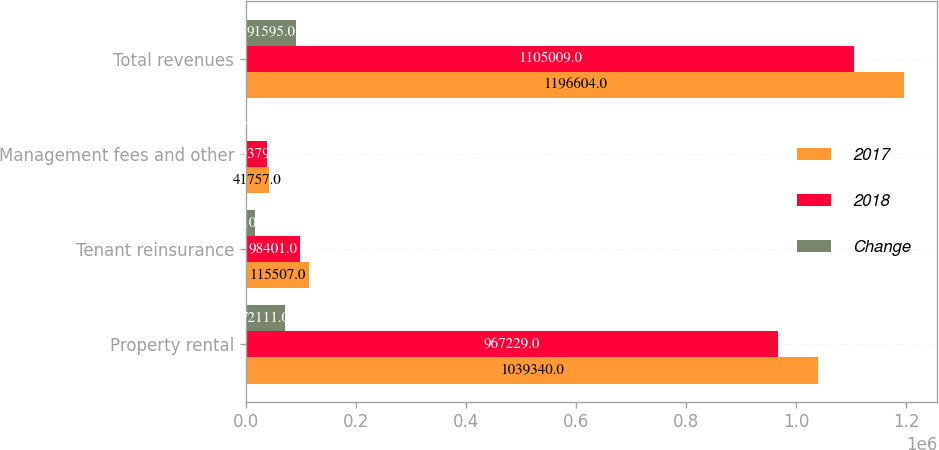Convert chart to OTSL. <chart><loc_0><loc_0><loc_500><loc_500><stacked_bar_chart><ecel><fcel>Property rental<fcel>Tenant reinsurance<fcel>Management fees and other<fcel>Total revenues<nl><fcel>2017<fcel>1.03934e+06<fcel>115507<fcel>41757<fcel>1.1966e+06<nl><fcel>2018<fcel>967229<fcel>98401<fcel>39379<fcel>1.10501e+06<nl><fcel>Change<fcel>72111<fcel>17106<fcel>2378<fcel>91595<nl></chart> 